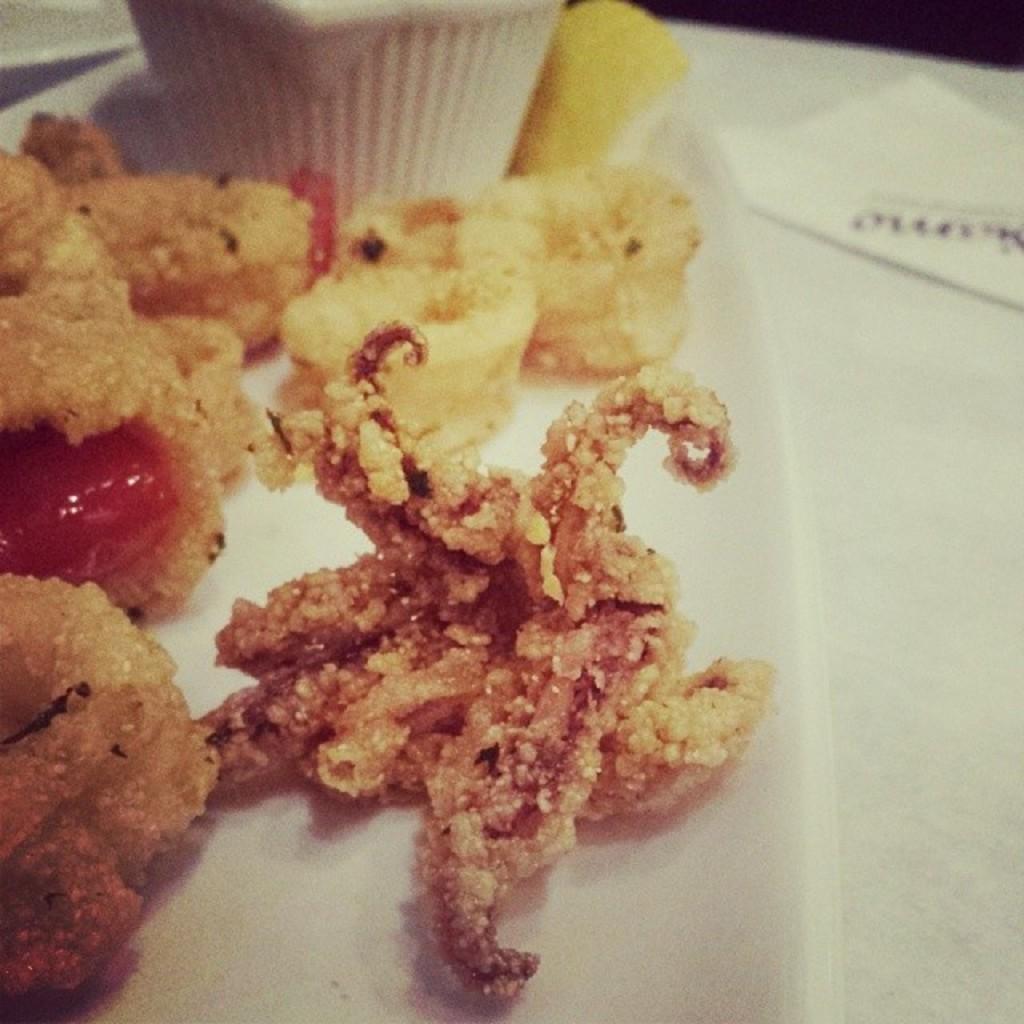Can you describe this image briefly? In this image I can see food which is in brown and red color on some surface. Background I can see a white color cup and few papers. 